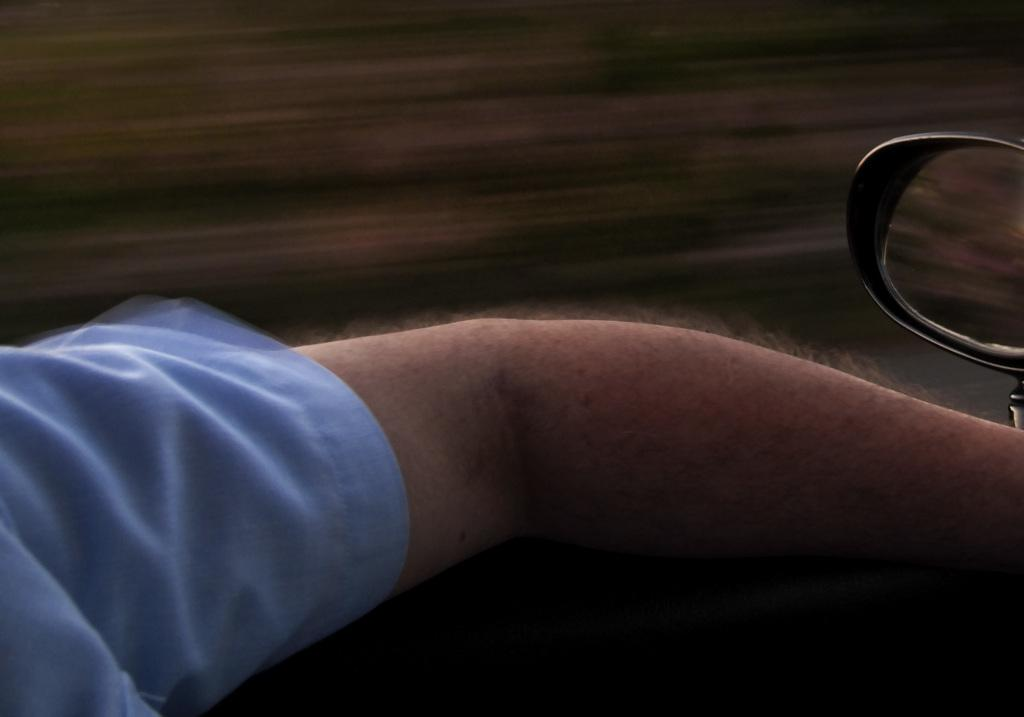What is the main subject in the foreground of the image? There is a hand in the foreground of the image. Where is the mirror located in the image? The mirror is in the right corner of the image. How would you describe the background of the image? The background of the image is blurry. How many cakes are being prepared in the image? There are no cakes present in the image. Is there a baseball game happening in the background of the image? There is no baseball game visible in the image. 